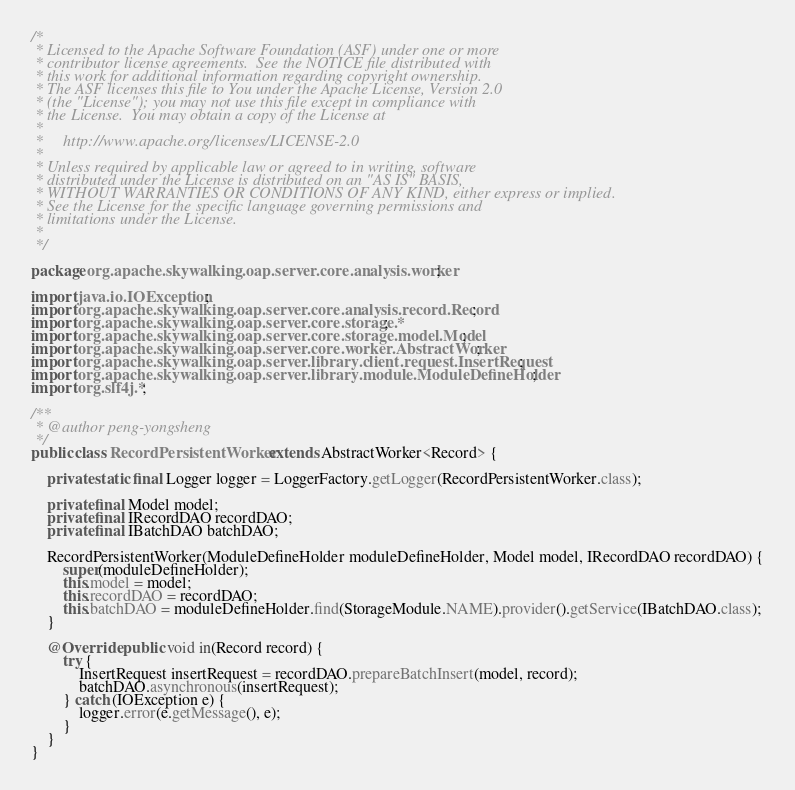Convert code to text. <code><loc_0><loc_0><loc_500><loc_500><_Java_>/*
 * Licensed to the Apache Software Foundation (ASF) under one or more
 * contributor license agreements.  See the NOTICE file distributed with
 * this work for additional information regarding copyright ownership.
 * The ASF licenses this file to You under the Apache License, Version 2.0
 * (the "License"); you may not use this file except in compliance with
 * the License.  You may obtain a copy of the License at
 *
 *     http://www.apache.org/licenses/LICENSE-2.0
 *
 * Unless required by applicable law or agreed to in writing, software
 * distributed under the License is distributed on an "AS IS" BASIS,
 * WITHOUT WARRANTIES OR CONDITIONS OF ANY KIND, either express or implied.
 * See the License for the specific language governing permissions and
 * limitations under the License.
 *
 */

package org.apache.skywalking.oap.server.core.analysis.worker;

import java.io.IOException;
import org.apache.skywalking.oap.server.core.analysis.record.Record;
import org.apache.skywalking.oap.server.core.storage.*;
import org.apache.skywalking.oap.server.core.storage.model.Model;
import org.apache.skywalking.oap.server.core.worker.AbstractWorker;
import org.apache.skywalking.oap.server.library.client.request.InsertRequest;
import org.apache.skywalking.oap.server.library.module.ModuleDefineHolder;
import org.slf4j.*;

/**
 * @author peng-yongsheng
 */
public class RecordPersistentWorker extends AbstractWorker<Record> {

    private static final Logger logger = LoggerFactory.getLogger(RecordPersistentWorker.class);

    private final Model model;
    private final IRecordDAO recordDAO;
    private final IBatchDAO batchDAO;

    RecordPersistentWorker(ModuleDefineHolder moduleDefineHolder, Model model, IRecordDAO recordDAO) {
        super(moduleDefineHolder);
        this.model = model;
        this.recordDAO = recordDAO;
        this.batchDAO = moduleDefineHolder.find(StorageModule.NAME).provider().getService(IBatchDAO.class);
    }

    @Override public void in(Record record) {
        try {
            InsertRequest insertRequest = recordDAO.prepareBatchInsert(model, record);
            batchDAO.asynchronous(insertRequest);
        } catch (IOException e) {
            logger.error(e.getMessage(), e);
        }
    }
}
</code> 